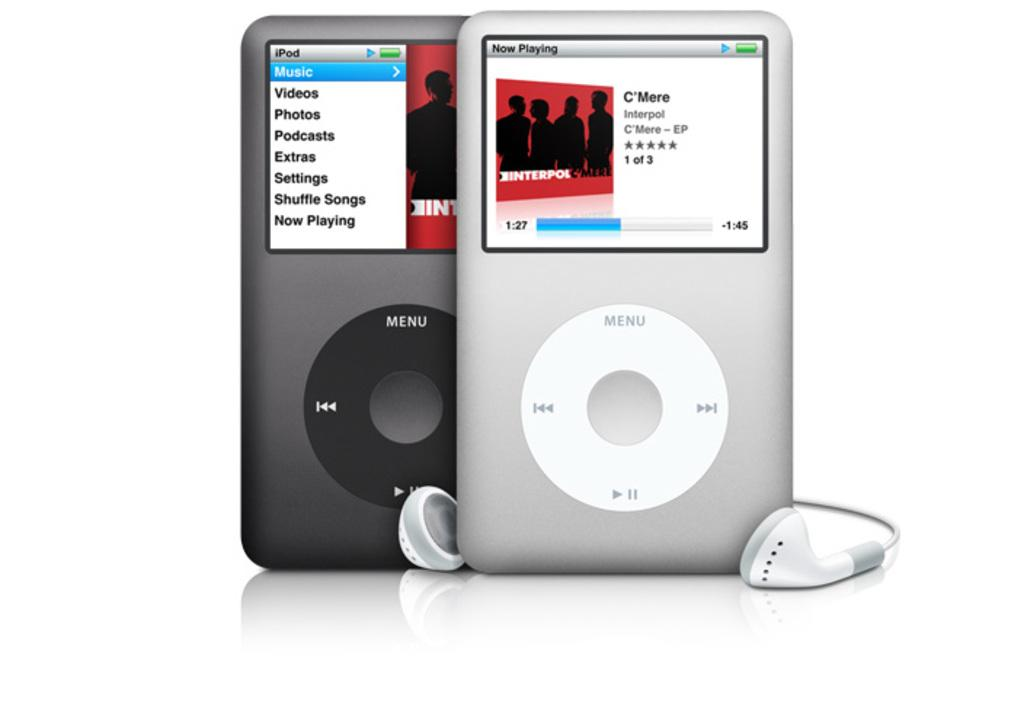What type of device is present in the image? There is a musical device in the image. What accessory is associated with the musical device? Headphones are visible in the image. What part of the man's body is the musical device attached to in the image? There is no man present in the image, and therefore no body part to which the musical device could be attached. 